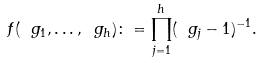<formula> <loc_0><loc_0><loc_500><loc_500>f ( \ g _ { 1 } , \dots , \ g _ { h } ) \colon = \prod _ { j = 1 } ^ { h } ( \ g _ { j } - 1 ) ^ { - 1 } .</formula> 